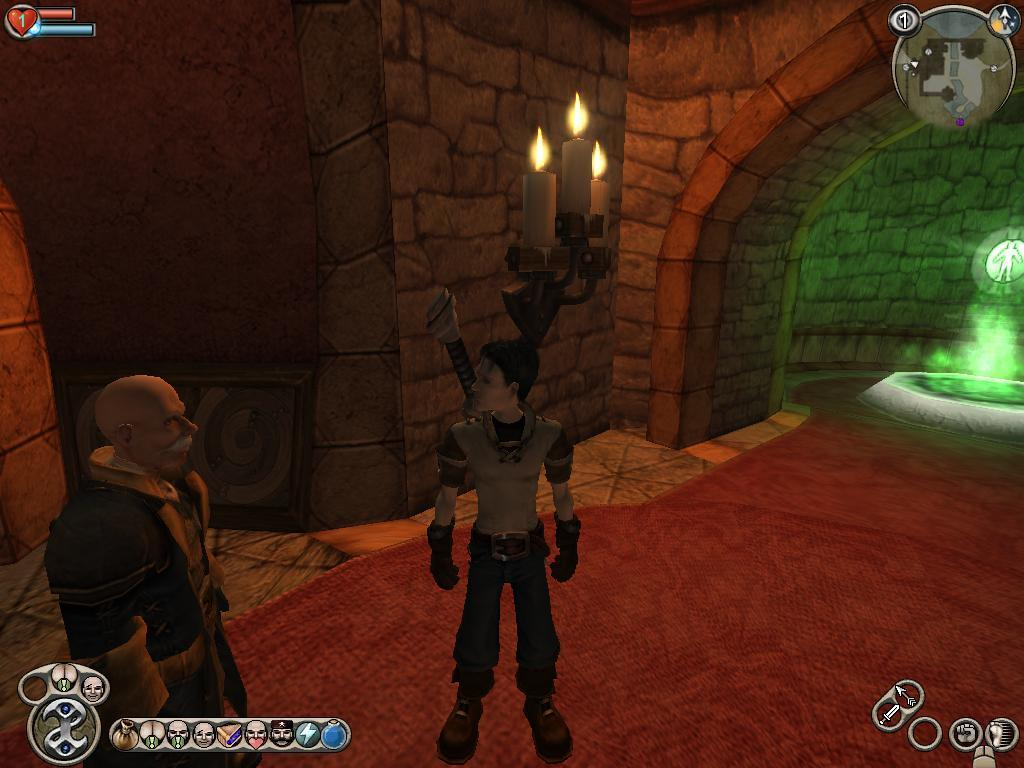What type of visual is the image? The image is an animation. Can you describe the main subjects in the image? There are two people in the center of the image. What is located at the bottom of the image? There is a carpet at the bottom of the image. What can be seen in the background of the image? There is a light and candles visible in the background of the image. How many dimes are exchanged between the two people in the image? There are no dimes present in the image, and no exchange is taking place between the two people. 